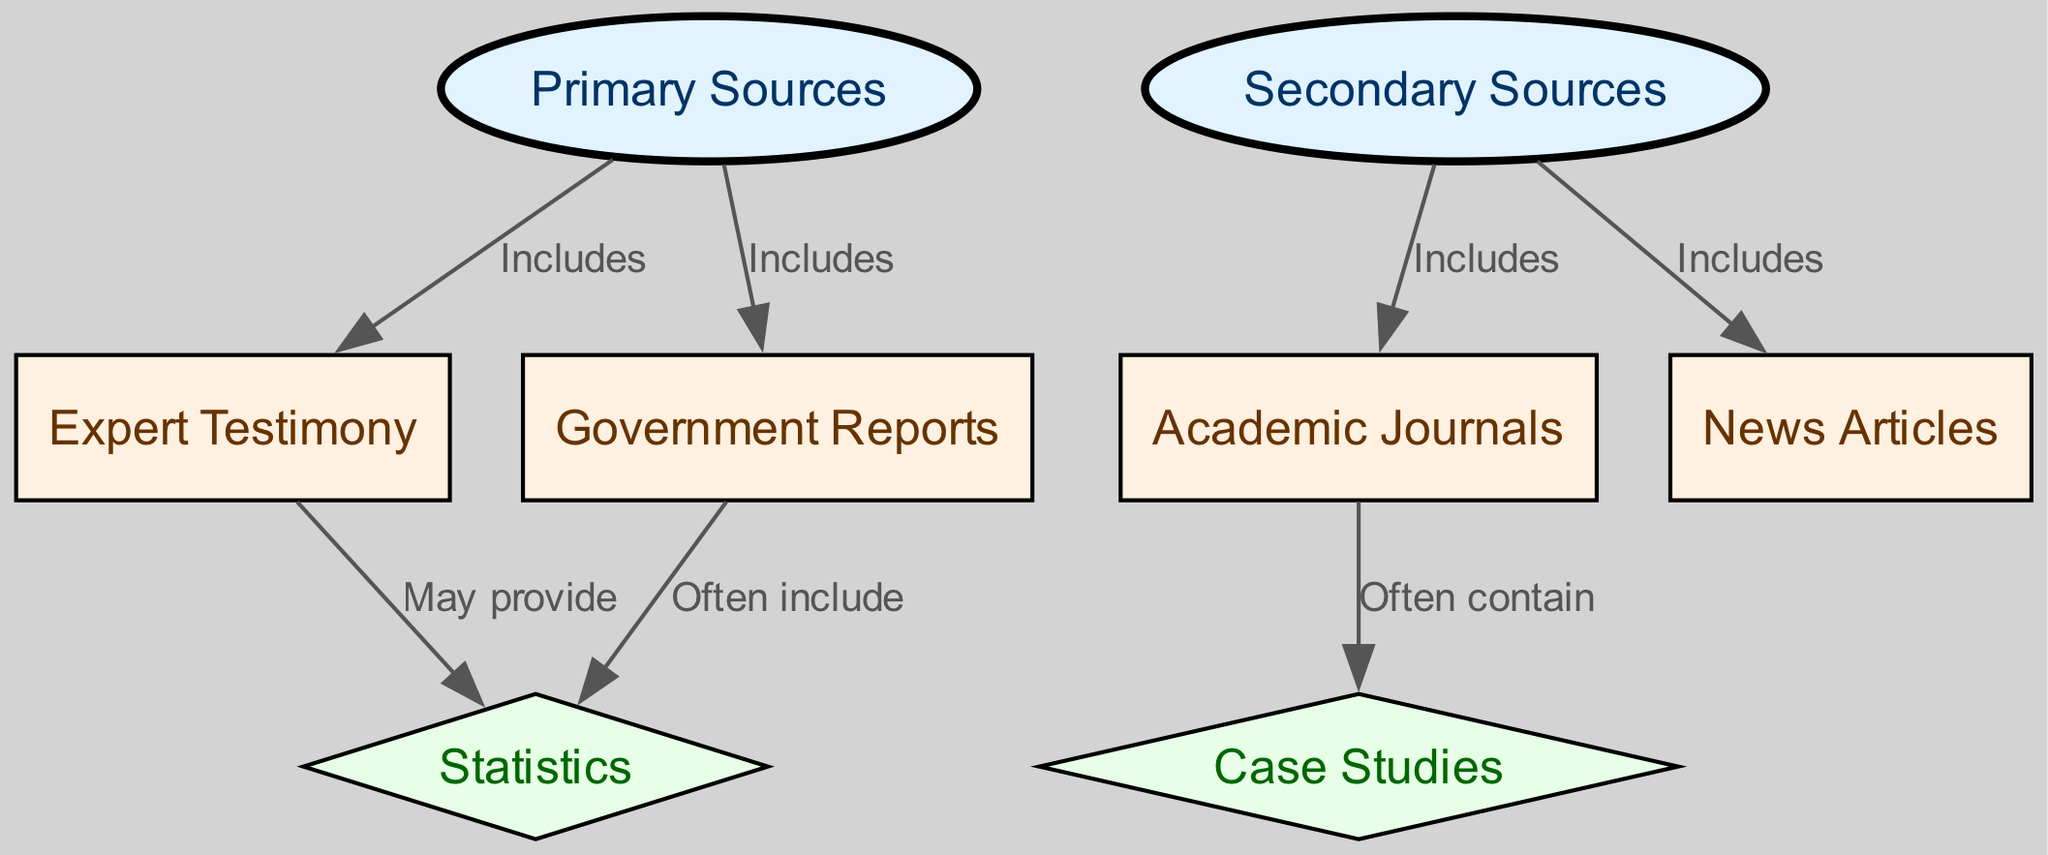What are the two main categories of sources in the diagram? The diagram shows two main categories of sources: "Primary Sources" and "Secondary Sources." These are the top-level nodes in the hierarchy that classify the types of evidence.
Answer: Primary Sources, Secondary Sources How many edges are there in the diagram? An edge represents a relationship between two nodes, and by counting them, we find there are a total of 7 edges connecting the different sources.
Answer: 7 Which node is included under Primary Sources? The diagram has "Expert Testimony" and "Government Reports" listed as nodes connected to "Primary Sources," indicating their inclusion.
Answer: Expert Testimony, Government Reports What type of source often includes statistics? The diagram indicates "Government Reports" often include "Statistics," showing a direct connection where Government Reports provide this type of evidence.
Answer: Government Reports What is often contained within Academic Journals? The diagram illustrates that "Case Studies" are a common component found within "Academic Journals," as represented by the directional edge from Academic Journals to Case Studies.
Answer: Case Studies If we consider Secondary Sources, what types of evidence are included? The diagram shows that "Academic Journals" and "News Articles" are included under "Secondary Sources," which specify the types of evidence within this category.
Answer: Academic Journals, News Articles What may Expert Testimony provide? According to the diagram, "Expert Testimony" may provide "Statistics," indicating that this form of evidence is often supplemented by numerical data.
Answer: Statistics Which node has the lowest level in the hierarchy? The lowest level nodes, indicated by a diamond shape, are "Statistics" and "Case Studies," which are the types of evidence under the respective higher nodes.
Answer: Statistics, Case Studies Which type of source is at the top of the hierarchy? The top of the hierarchy is occupied by "Primary Sources" and "Secondary Sources," which serve as the main categories or classifications in the diagram.
Answer: Primary Sources, Secondary Sources 